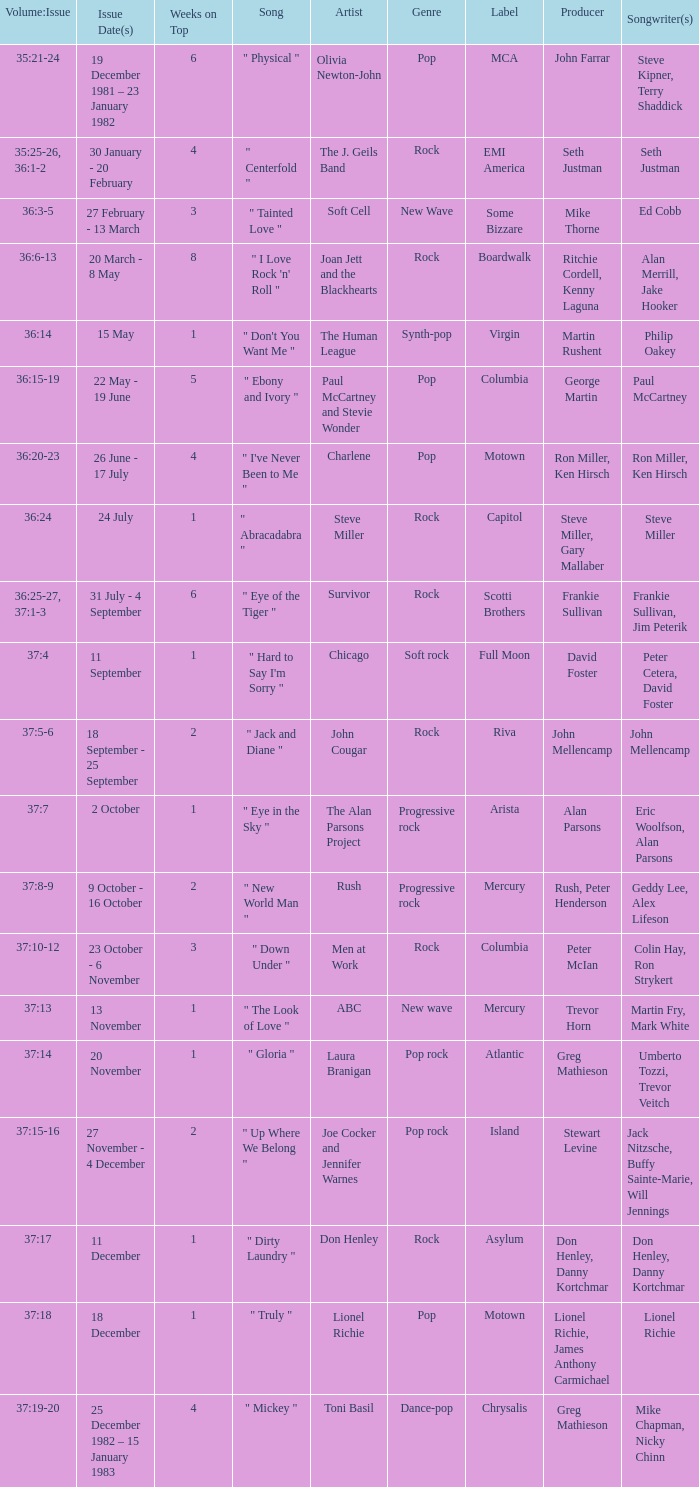Which Issue Date(s) has Weeks on Top larger than 3, and a Volume: Issue of 35:25-26, 36:1-2? 30 January - 20 February. I'm looking to parse the entire table for insights. Could you assist me with that? {'header': ['Volume:Issue', 'Issue Date(s)', 'Weeks on Top', 'Song', 'Artist', 'Genre', 'Label', 'Producer', 'Songwriter(s) '], 'rows': [['35:21-24', '19 December 1981 – 23 January 1982', '6', '" Physical "', 'Olivia Newton-John', 'Pop', 'MCA', 'John Farrar', 'Steve Kipner, Terry Shaddick'], ['35:25-26, 36:1-2', '30 January - 20 February', '4', '" Centerfold "', 'The J. Geils Band', 'Rock', 'EMI America', 'Seth Justman', 'Seth Justman'], ['36:3-5', '27 February - 13 March', '3', '" Tainted Love "', 'Soft Cell', 'New Wave', 'Some Bizzare', 'Mike Thorne', 'Ed Cobb'], ['36:6-13', '20 March - 8 May', '8', '" I Love Rock \'n\' Roll "', 'Joan Jett and the Blackhearts', 'Rock', 'Boardwalk', 'Ritchie Cordell, Kenny Laguna', 'Alan Merrill, Jake Hooker'], ['36:14', '15 May', '1', '" Don\'t You Want Me "', 'The Human League', 'Synth-pop', 'Virgin', 'Martin Rushent', 'Philip Oakey'], ['36:15-19', '22 May - 19 June', '5', '" Ebony and Ivory "', 'Paul McCartney and Stevie Wonder', 'Pop', 'Columbia', 'George Martin', 'Paul McCartney'], ['36:20-23', '26 June - 17 July', '4', '" I\'ve Never Been to Me "', 'Charlene', 'Pop', 'Motown', 'Ron Miller, Ken Hirsch', 'Ron Miller, Ken Hirsch'], ['36:24', '24 July', '1', '" Abracadabra "', 'Steve Miller', 'Rock', 'Capitol', 'Steve Miller, Gary Mallaber', 'Steve Miller'], ['36:25-27, 37:1-3', '31 July - 4 September', '6', '" Eye of the Tiger "', 'Survivor', 'Rock', 'Scotti Brothers', 'Frankie Sullivan', 'Frankie Sullivan, Jim Peterik'], ['37:4', '11 September', '1', '" Hard to Say I\'m Sorry "', 'Chicago', 'Soft rock', 'Full Moon', 'David Foster', 'Peter Cetera, David Foster'], ['37:5-6', '18 September - 25 September', '2', '" Jack and Diane "', 'John Cougar', 'Rock', 'Riva', 'John Mellencamp', 'John Mellencamp'], ['37:7', '2 October', '1', '" Eye in the Sky "', 'The Alan Parsons Project', 'Progressive rock', 'Arista', 'Alan Parsons', 'Eric Woolfson, Alan Parsons'], ['37:8-9', '9 October - 16 October', '2', '" New World Man "', 'Rush', 'Progressive rock', 'Mercury', 'Rush, Peter Henderson', 'Geddy Lee, Alex Lifeson'], ['37:10-12', '23 October - 6 November', '3', '" Down Under "', 'Men at Work', 'Rock', 'Columbia', 'Peter McIan', 'Colin Hay, Ron Strykert'], ['37:13', '13 November', '1', '" The Look of Love "', 'ABC', 'New wave', 'Mercury', 'Trevor Horn', 'Martin Fry, Mark White'], ['37:14', '20 November', '1', '" Gloria "', 'Laura Branigan', 'Pop rock', 'Atlantic', 'Greg Mathieson', 'Umberto Tozzi, Trevor Veitch'], ['37:15-16', '27 November - 4 December', '2', '" Up Where We Belong "', 'Joe Cocker and Jennifer Warnes', 'Pop rock', 'Island', 'Stewart Levine', 'Jack Nitzsche, Buffy Sainte-Marie, Will Jennings'], ['37:17', '11 December', '1', '" Dirty Laundry "', 'Don Henley', 'Rock', 'Asylum', 'Don Henley, Danny Kortchmar', 'Don Henley, Danny Kortchmar '], ['37:18', '18 December', '1', '" Truly "', 'Lionel Richie', 'Pop', 'Motown', 'Lionel Richie, James Anthony Carmichael', 'Lionel Richie'], ['37:19-20', '25 December 1982 – 15 January 1983', '4', '" Mickey "', 'Toni Basil', 'Dance-pop', 'Chrysalis', 'Greg Mathieson', 'Mike Chapman, Nicky Chinn']]} 